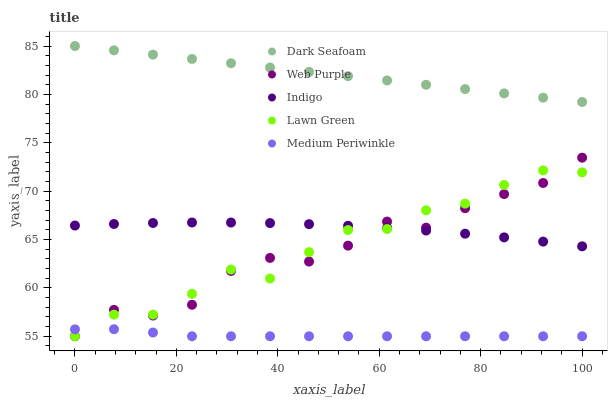Does Medium Periwinkle have the minimum area under the curve?
Answer yes or no. Yes. Does Dark Seafoam have the maximum area under the curve?
Answer yes or no. Yes. Does Indigo have the minimum area under the curve?
Answer yes or no. No. Does Indigo have the maximum area under the curve?
Answer yes or no. No. Is Dark Seafoam the smoothest?
Answer yes or no. Yes. Is Web Purple the roughest?
Answer yes or no. Yes. Is Indigo the smoothest?
Answer yes or no. No. Is Indigo the roughest?
Answer yes or no. No. Does Lawn Green have the lowest value?
Answer yes or no. Yes. Does Indigo have the lowest value?
Answer yes or no. No. Does Dark Seafoam have the highest value?
Answer yes or no. Yes. Does Indigo have the highest value?
Answer yes or no. No. Is Medium Periwinkle less than Dark Seafoam?
Answer yes or no. Yes. Is Dark Seafoam greater than Web Purple?
Answer yes or no. Yes. Does Indigo intersect Lawn Green?
Answer yes or no. Yes. Is Indigo less than Lawn Green?
Answer yes or no. No. Is Indigo greater than Lawn Green?
Answer yes or no. No. Does Medium Periwinkle intersect Dark Seafoam?
Answer yes or no. No. 